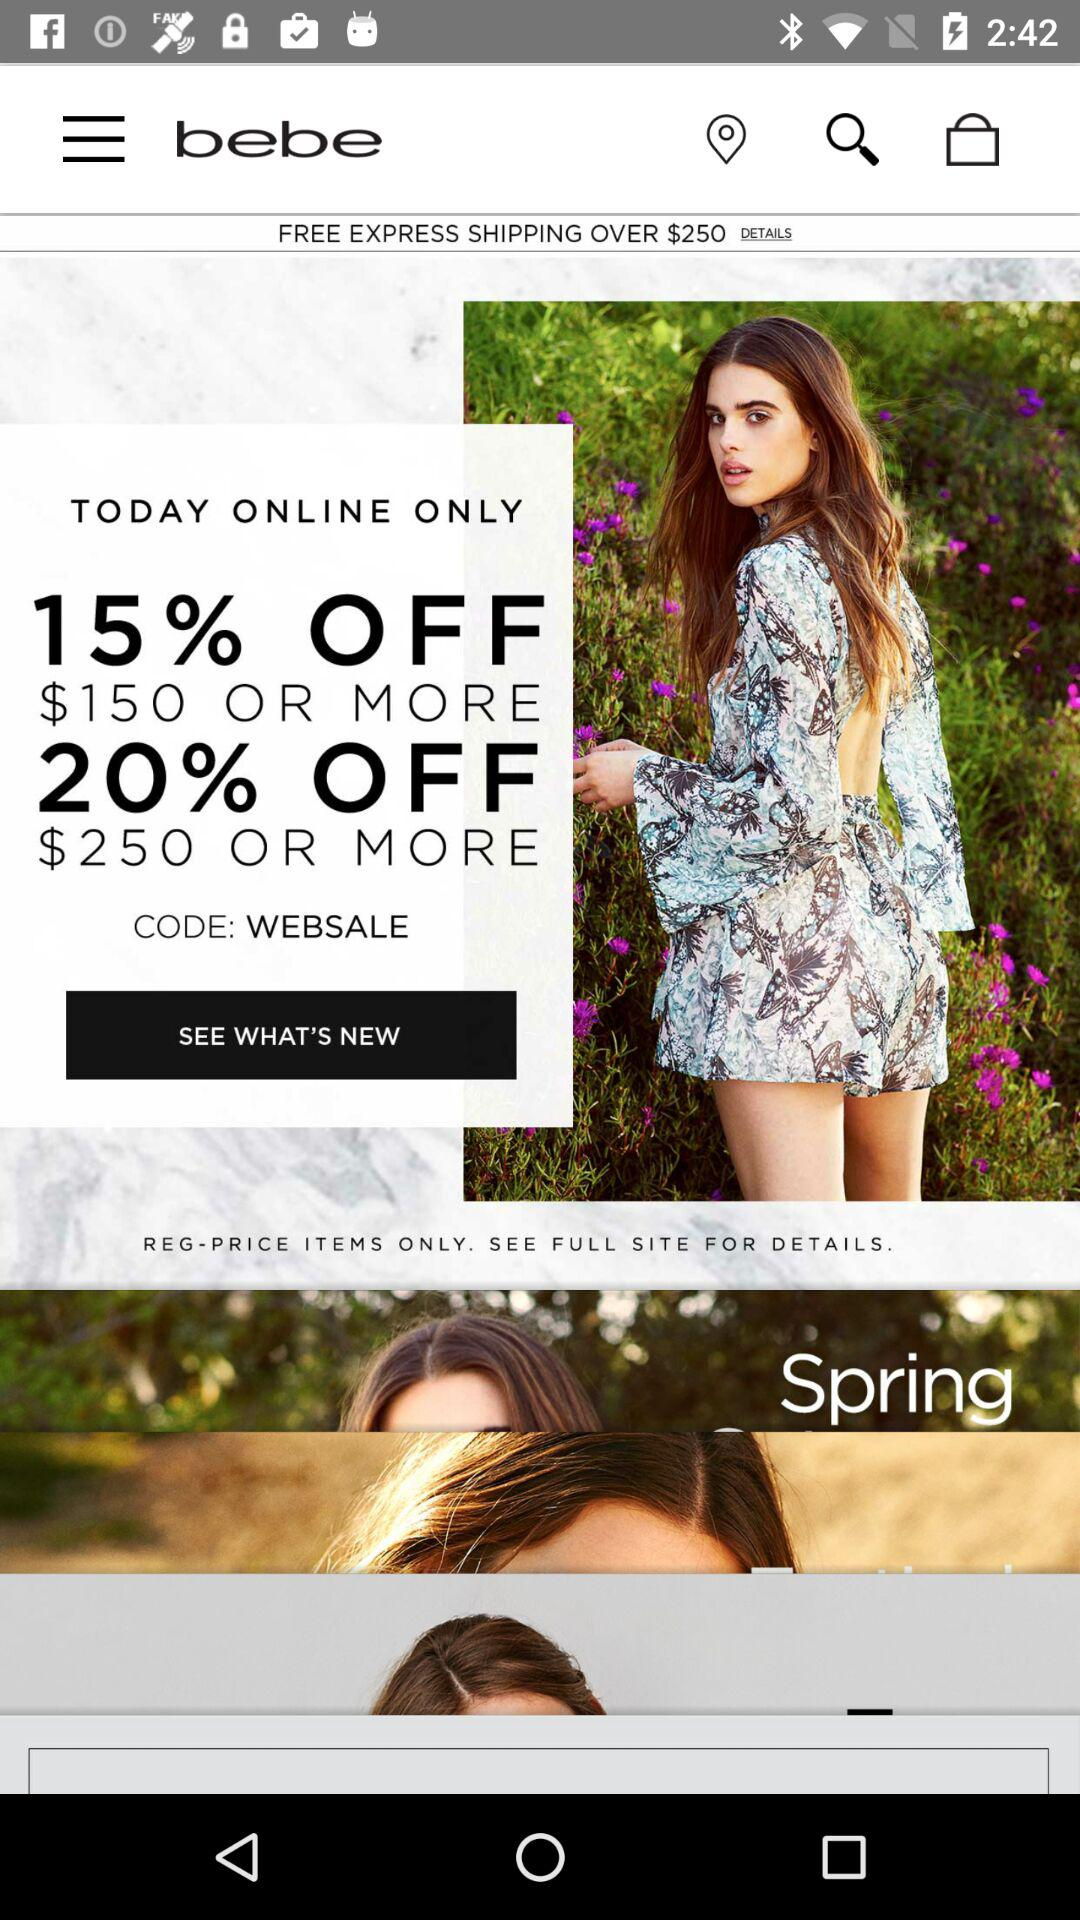What is the code? The code is "WEBSALE". 